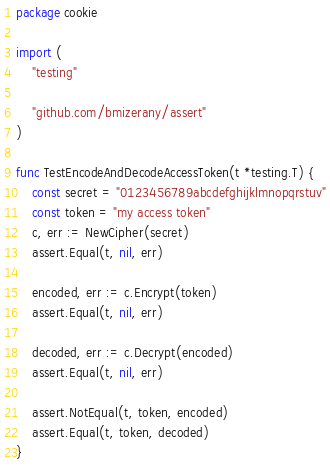<code> <loc_0><loc_0><loc_500><loc_500><_Go_>package cookie

import (
	"testing"

	"github.com/bmizerany/assert"
)

func TestEncodeAndDecodeAccessToken(t *testing.T) {
	const secret = "0123456789abcdefghijklmnopqrstuv"
	const token = "my access token"
	c, err := NewCipher(secret)
	assert.Equal(t, nil, err)

	encoded, err := c.Encrypt(token)
	assert.Equal(t, nil, err)

	decoded, err := c.Decrypt(encoded)
	assert.Equal(t, nil, err)

	assert.NotEqual(t, token, encoded)
	assert.Equal(t, token, decoded)
}
</code> 